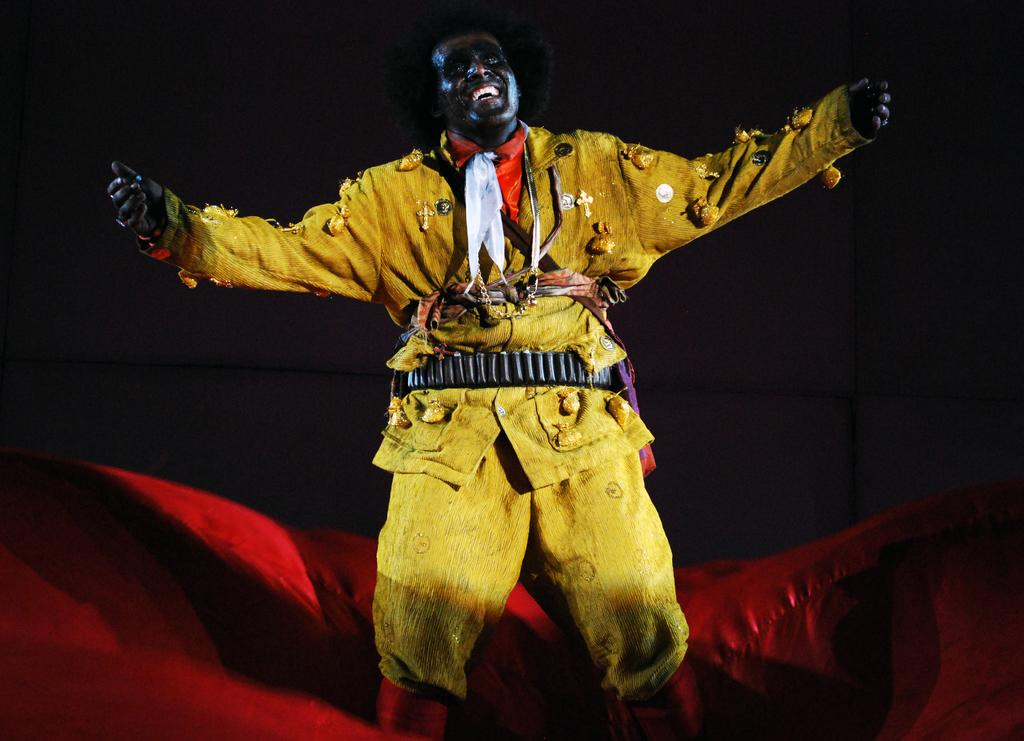Who is present in the image? There is a man in the image. What is the man wearing? The man is wearing a yellow dress. What is the man doing in the image? The man is dancing. What color is the background of the image? The background of the image is black. What can be seen on the floor in the image? There is a red color cloth on the floor in the image. What type of creature is shown interacting with the honey in the image? There is no creature or honey present in the image; it features a man dancing in a yellow dress against a black background with a red cloth on the floor. 